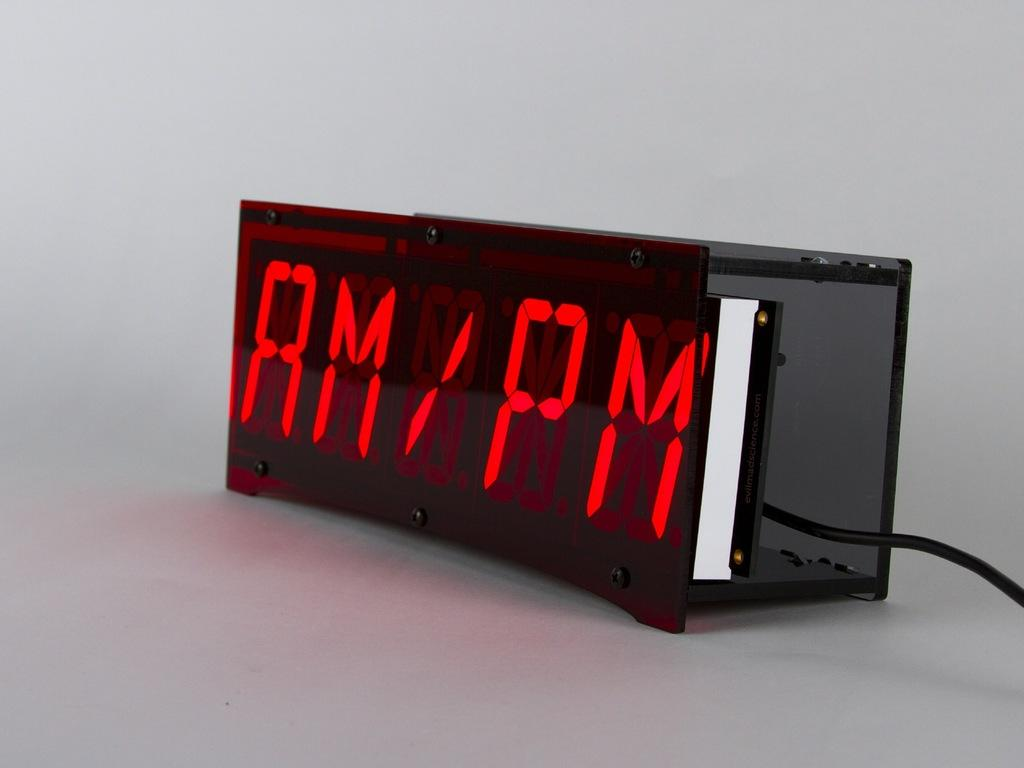<image>
Give a short and clear explanation of the subsequent image. An electronic device that has both AM and PM written on it. 